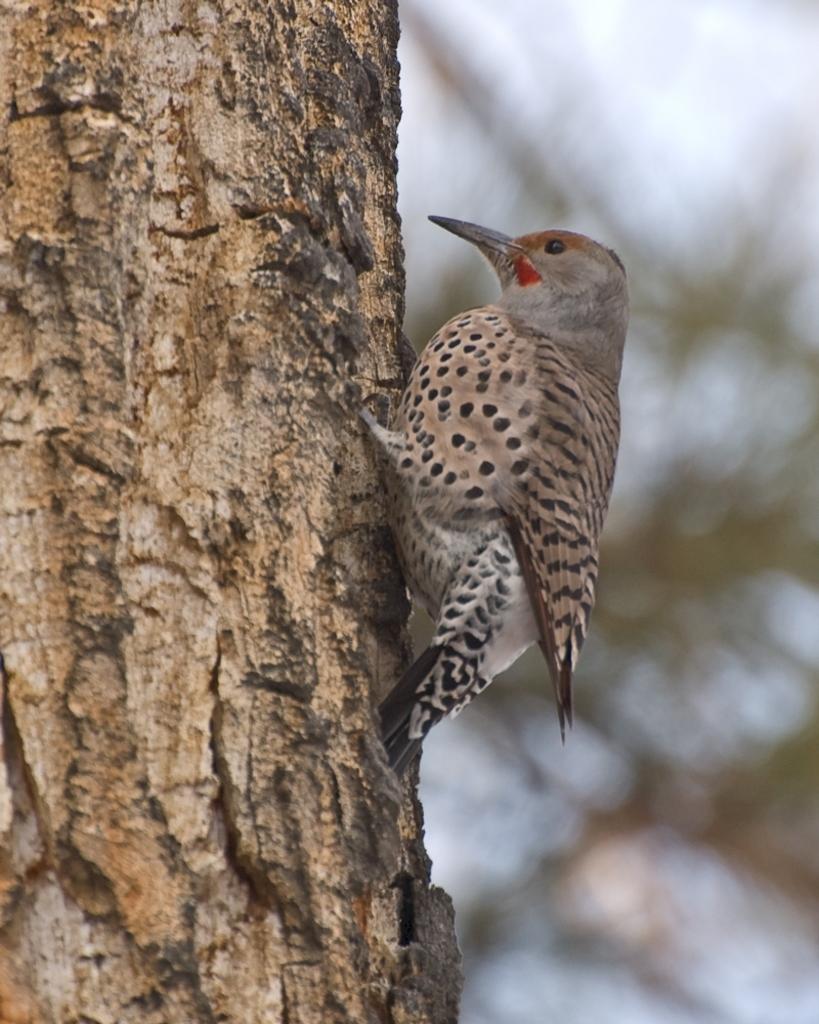In one or two sentences, can you explain what this image depicts? This picture might be taken from outside of the city. In this image, in the middle, we can see a bird standing on the tree stem. In the background, we can also see some trees and a sky. 